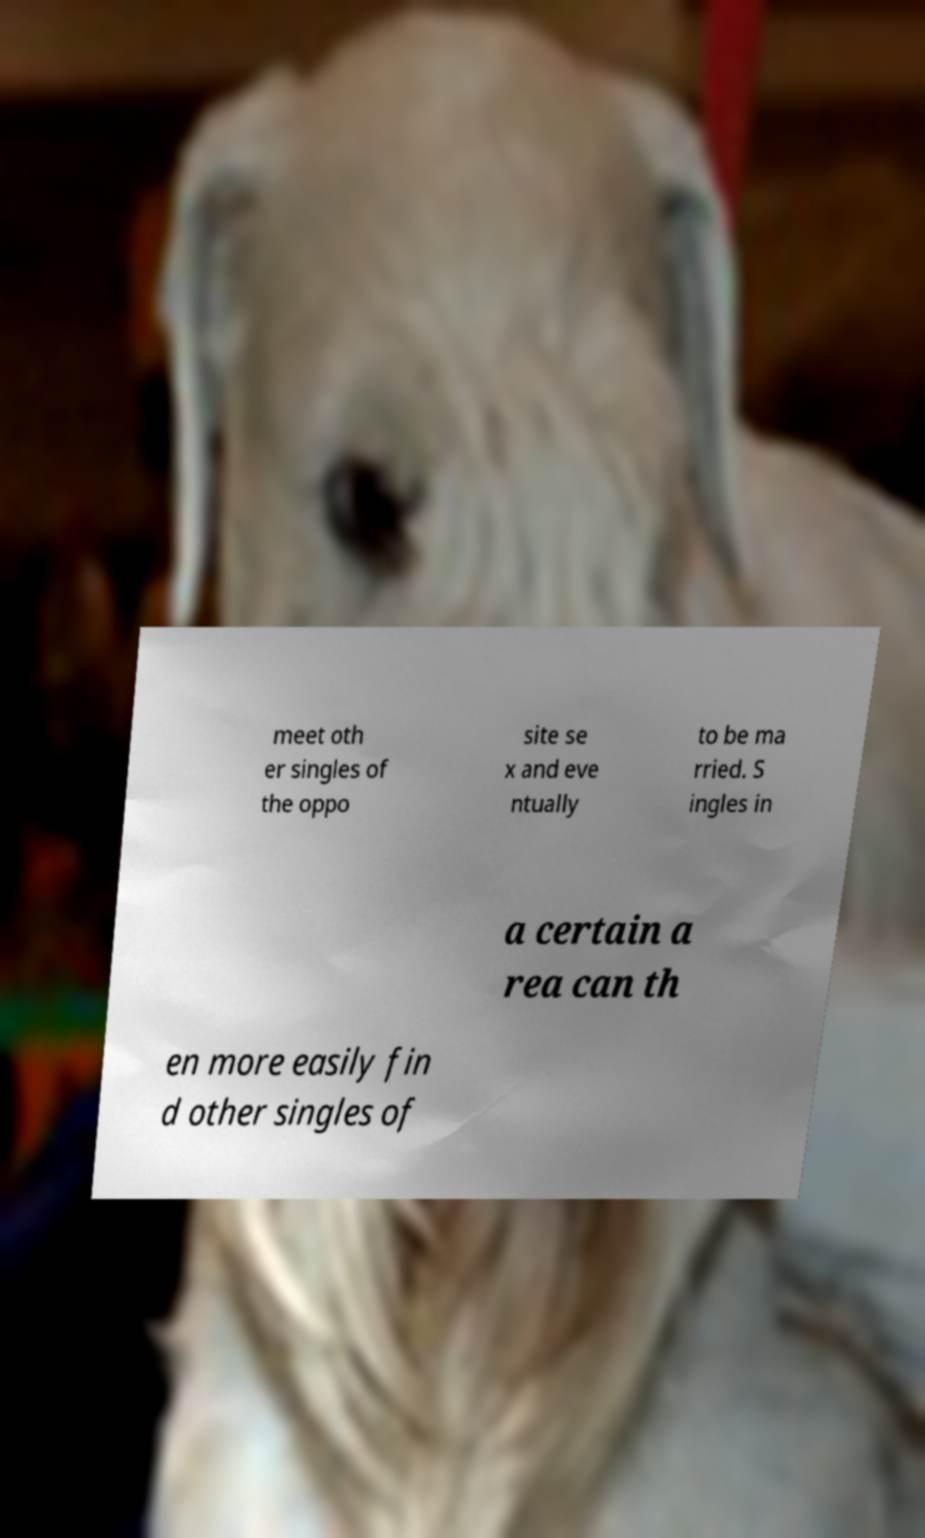Could you extract and type out the text from this image? meet oth er singles of the oppo site se x and eve ntually to be ma rried. S ingles in a certain a rea can th en more easily fin d other singles of 